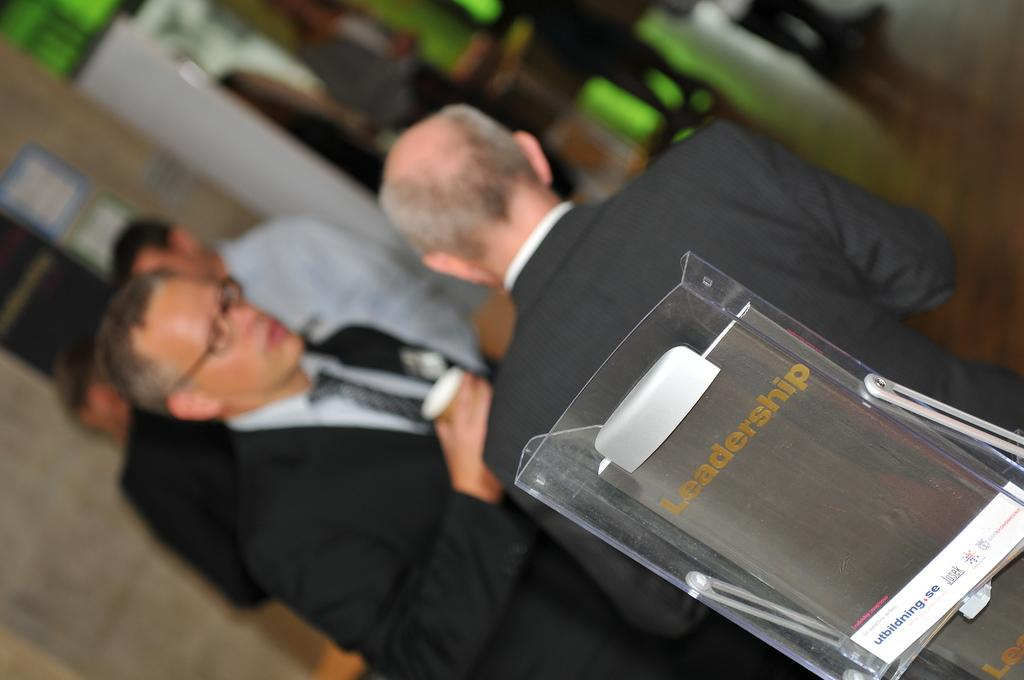What objects are on the glass stand in the image? There are books on a glass stand in the image. What can be seen in the background of the image? There is a group of people standing and boards on the wall in the background of the image. How is the background of the image depicted? The background of the image is blurred. Who is the creator of the bridge in the image? There is no bridge present in the image. 